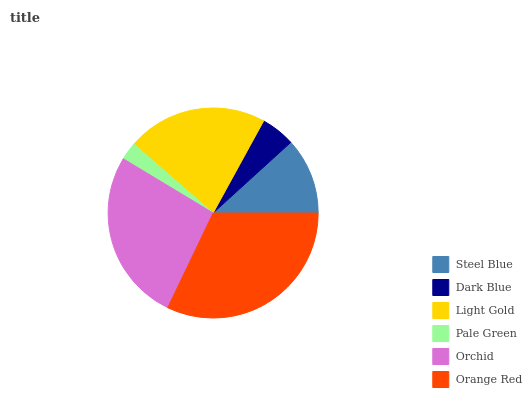Is Pale Green the minimum?
Answer yes or no. Yes. Is Orange Red the maximum?
Answer yes or no. Yes. Is Dark Blue the minimum?
Answer yes or no. No. Is Dark Blue the maximum?
Answer yes or no. No. Is Steel Blue greater than Dark Blue?
Answer yes or no. Yes. Is Dark Blue less than Steel Blue?
Answer yes or no. Yes. Is Dark Blue greater than Steel Blue?
Answer yes or no. No. Is Steel Blue less than Dark Blue?
Answer yes or no. No. Is Light Gold the high median?
Answer yes or no. Yes. Is Steel Blue the low median?
Answer yes or no. Yes. Is Pale Green the high median?
Answer yes or no. No. Is Orchid the low median?
Answer yes or no. No. 